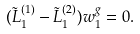<formula> <loc_0><loc_0><loc_500><loc_500>( \tilde { L } _ { 1 } ^ { ( 1 ) } - \tilde { L } _ { 1 } ^ { ( 2 ) } ) w _ { 1 } ^ { g } = 0 .</formula> 